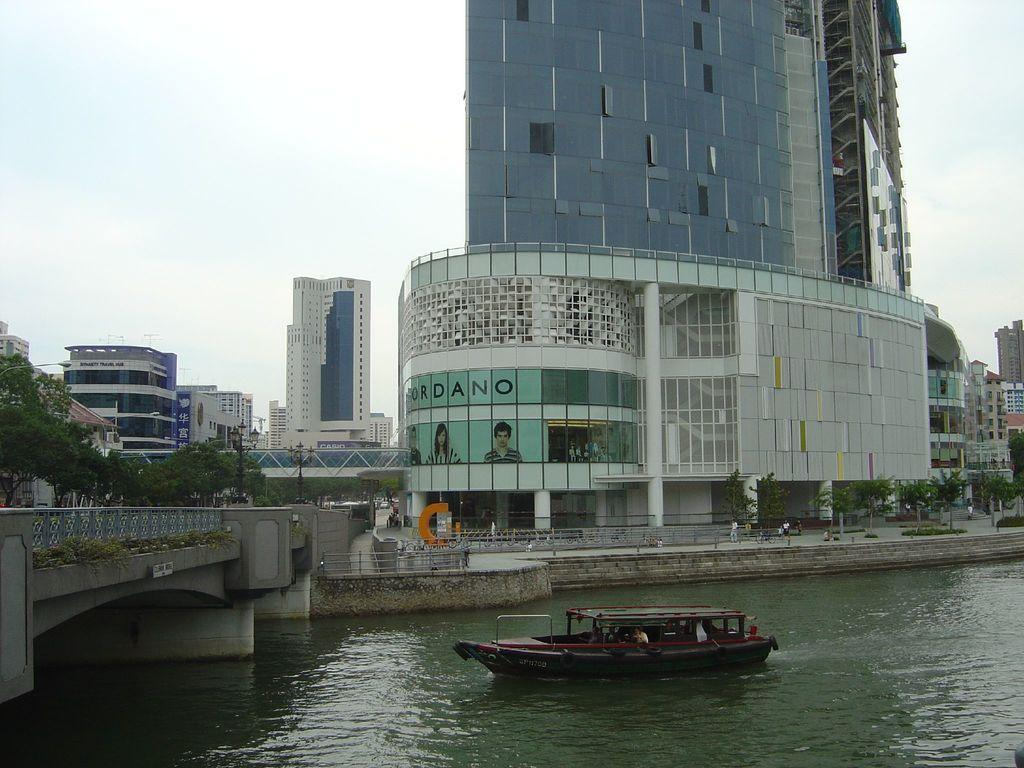What is on the water in the image? There is a boat on the water in the image. What type of structures can be seen in the image? There are buildings in the image. What type of vegetation is present in the image? Trees are present in the image. What architectural feature connects the two sides of the water? There is a bridge in the image. What are the poles used for in the image? The purpose of the poles is not specified in the image. What might be used for walking on in the image? Boards are present in the image, which could be used for walking on. What type of barrier is visible in the image? A fence is visible in the image. What can be seen in the background of the image? The sky is visible in the background of the image. What type of shop can be seen in the image? There is no shop present in the image. What letters are visible on the boat in the image? There are no letters visible on the boat in the image. 